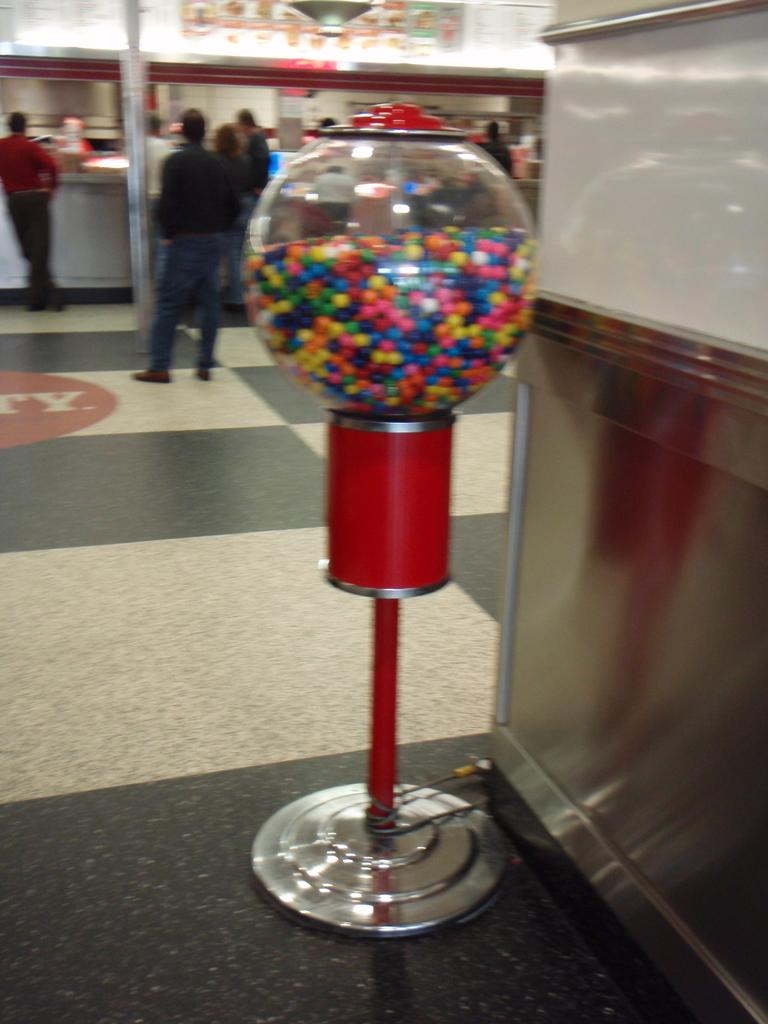What is the main object in the foreground of the picture? There is an iron object in the foreground of the picture. What is located next to the iron object in the foreground? There is a stand in the foreground of the picture. What can be seen on the floor in the foreground of the picture? The floor is visible in the foreground of the picture, and candies are present on it. What is visible in the background of the picture? There are stalls, people, and various other objects in the background of the picture. What type of treatment is being administered to the goldfish in the picture? There is no goldfish present in the picture, so no treatment can be administered. What type of insurance policy is being discussed by the people in the background of the picture? There is no indication in the picture that the people in the background are discussing insurance policies. 